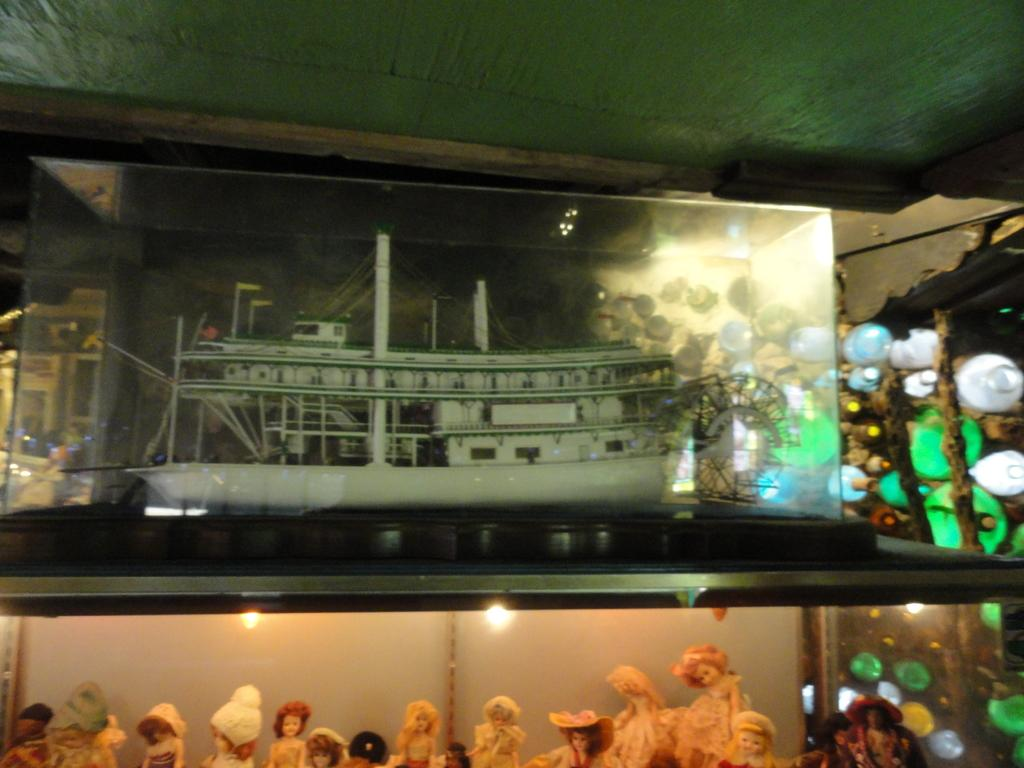What type of objects can be seen in the image? There are dolls and water bottles in the image. What is depicted in the painting in the image? There is a painting of a ship in the image. What color is the sheet at the top of the image? There is a green color sheet at the top of the image. Can you see a tub filled with water in the image? There is no tub filled with water present in the image. How many fingers are visible on the dolls in the image? The image does not show the dolls' fingers, so it cannot be determined from the image. 